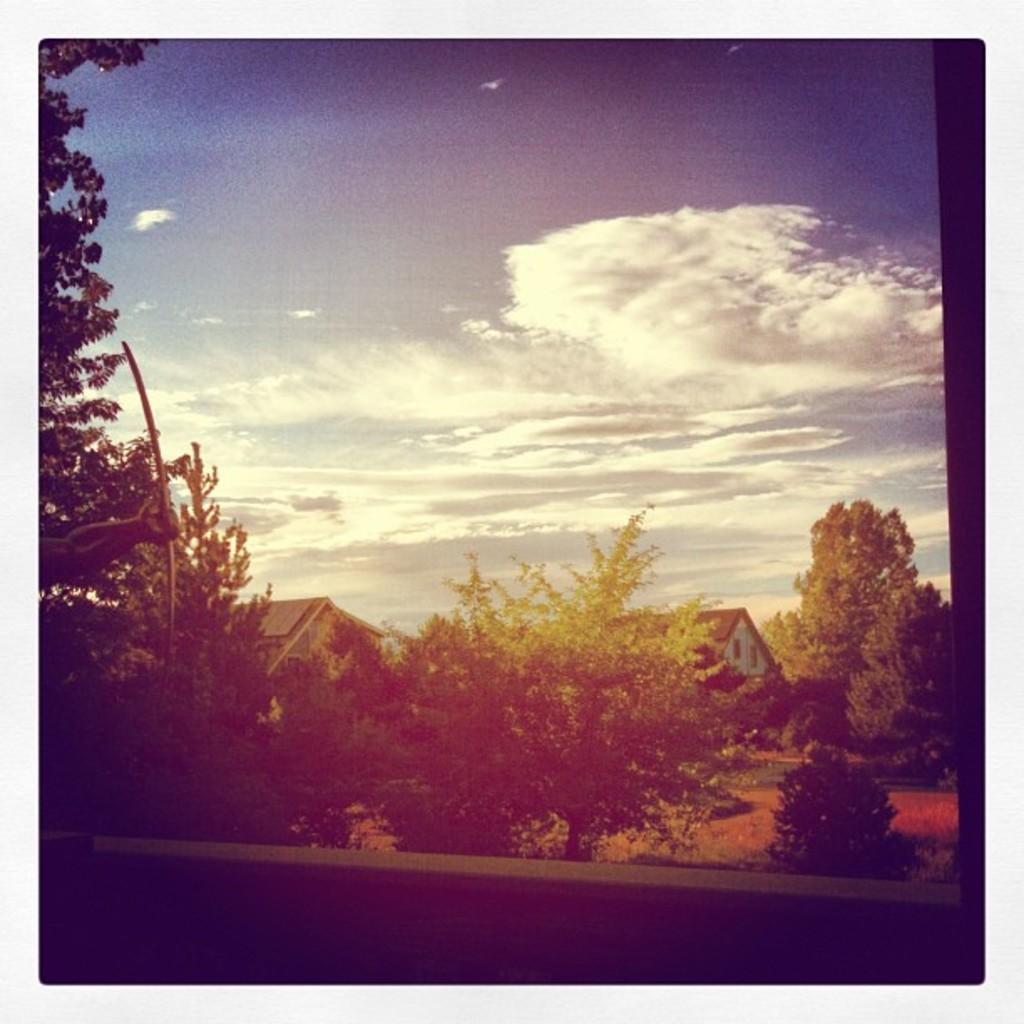In one or two sentences, can you explain what this image depicts? In the center of the image there are seeds and trees. In the background there is sky. 